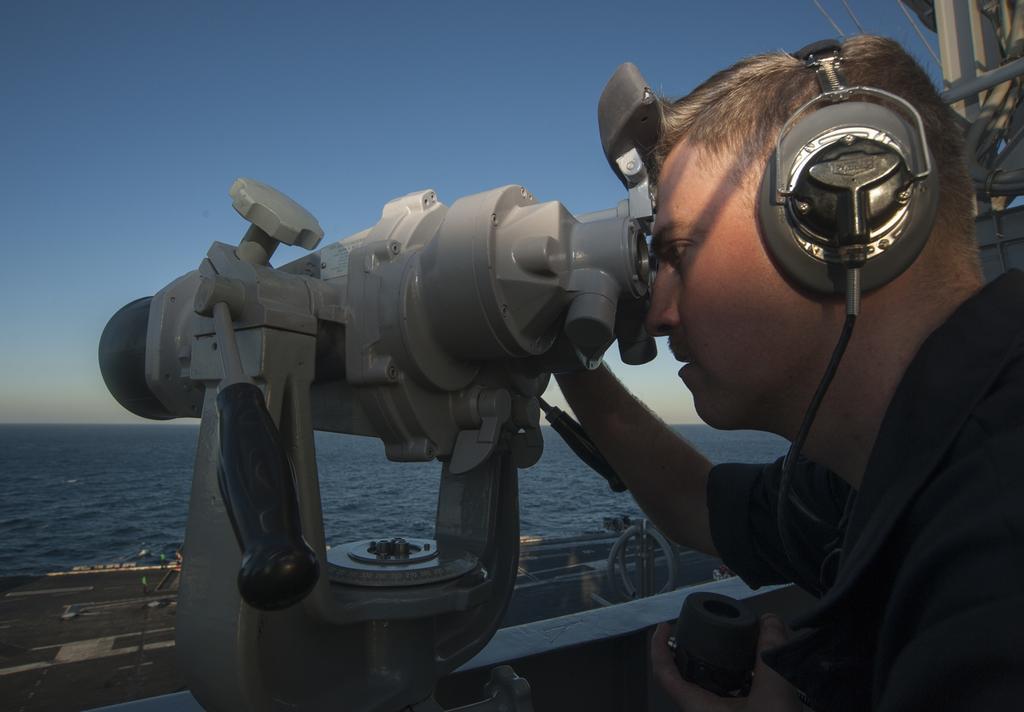In one or two sentences, can you explain what this image depicts? In this image, we can see a person holding a binoculars and wearing headset. In the background, there is sea and at the top, there is sky. 